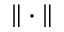<formula> <loc_0><loc_0><loc_500><loc_500>\| \cdot \|</formula> 